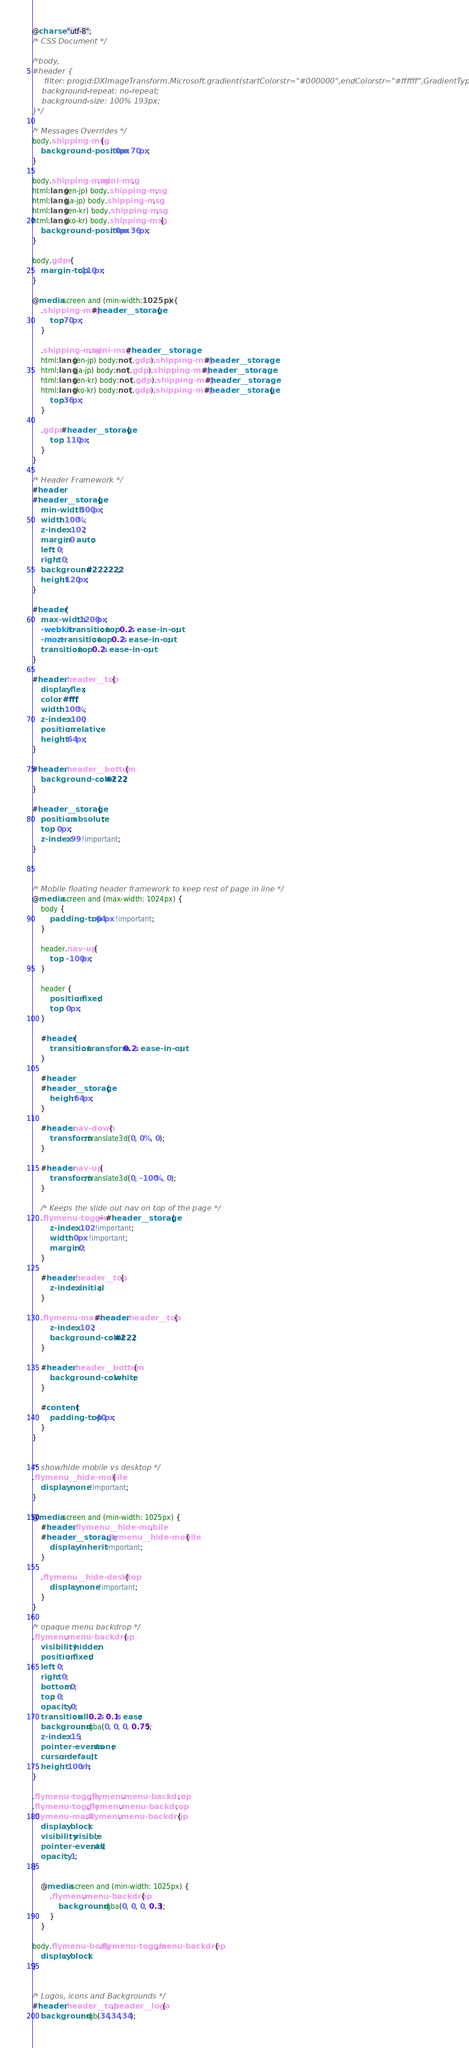Convert code to text. <code><loc_0><loc_0><loc_500><loc_500><_CSS_>@charset "utf-8";
/* CSS Document */

/*body,
#header {
     filter: progid:DXImageTransform.Microsoft.gradient(startColorstr="#000000",endColorstr="#ffffff",GradientType=1);
    background-repeat: no-repeat;
    background-size: 100% 193px; 
}*/

/* Messages Overrides */
body.shipping-msg {
    background-position: 0px 70px;
}

body.shipping-msg.mini-msg,
html:lang(en-jp) body.shipping-msg,
html:lang(ja-jp) body.shipping-msg,
html:lang(en-kr) body.shipping-msg,
html:lang(ko-kr) body.shipping-msg  {
    background-position: 0px 36px;
}

body.gdpr {
    margin-top:110px;
}

@media screen and (min-width:1025px) {
    .shipping-msg #header__storage {
        top:70px;
    }
    
    .shipping-msg.mini-msg #header__storage,
    html:lang(en-jp) body:not(.gdpr).shipping-msg #header__storage,
    html:lang(ja-jp) body:not(.gdpr).shipping-msg #header__storage,
    html:lang(en-kr) body:not(.gdpr).shipping-msg #header__storage,
    html:lang(ko-kr) body:not(.gdpr).shipping-msg #header__storage {
        top:36px;
    }
    
    .gdpr #header__storage {
        top: 110px;
    }
}

/* Header Framework */
#header,
#header__storage {
    min-width: 300px;
    width: 100%;
    z-index: 102;
    margin: 0 auto;
    left: 0;
    right: 0;
    background: #222222;
    height:120px;
}

#header {
    max-width:1200px;
    -webkit-transition: top 0.2s ease-in-out;
    -moz-transition: top 0.2s ease-in-out;
    transition: top 0.2s ease-in-out;
}

#header .header__top {
    display: flex;
    color: #fff;
    width: 100%;
    z-index: 100;
    position: relative;
    height: 64px;
}

#header .header__bottom {
    background-color: #222;
}

#header__storage {
    position: absolute;
    top: 0px;
    z-index: 99 !important;
}



/* Mobile floating header framework to keep rest of page in line */
@media screen and (max-width: 1024px) {
    body {
        padding-top: 64px !important;
    }

    header.nav-up {
        top: -100px;
    }

    header {
        position: fixed;
        top: 0px;
    }

    #header {
        transition: transform 0.2s ease-in-out;
    }

    #header,
    #header__storage {
        height:64px;
    }

    #header.nav-down {
        transform: translate3d(0, 0%, 0);
    }

    #header.nav-up {
        transform: translate3d(0, -100%, 0);
    }

    /* Keeps the slide out nav on top of the page */
    .flymenu-toggle ~ #header__storage {
        z-index: 102 !important;
        width: 0px !important;
        margin: 0;
    }

    #header .header__top {
        z-index: initial;
    }

    .flymenu-mask #header .header__top {
        z-index: 102;
        background-color: #222;
    }

    #header .header__bottom {
        background-color: white;
    }

    #content {
        padding-top: 40px;
    }
}


/* show/hide mobile vs desktop */
.flymenu__hide-mobile {
    display: none !important;
}

@media screen and (min-width: 1025px) {
    #header .flymenu__hide-mobile,
    #header__storage .flymenu__hide-mobile {
        display: inherit !important;
    }

    .flymenu__hide-desktop {
        display: none !important;
    }
}

/* opaque menu backdrop */
.flymenu .menu-backdrop {
    visibility: hidden;
    position: fixed;
    left: 0;
    right: 0;
    bottom: 0;
    top: 0;
    opacity: 0;
    transition: all 0.2s 0.1s ease;
    background: rgba(0, 0, 0, 0.75);
    z-index: 15;
    pointer-events: none;
    cursor: default;
    height: 100vh;
}

.flymenu-toggle .flymenu .menu-backdrop,
.flymenu-toggle.flymenu .menu-backdrop,
.flymenu-mask .flymenu .menu-backdrop {
    display: block;
    visibility: visible;
    pointer-events: all;
    opacity: 1;
}

    @media screen and (min-width: 1025px) {
        .flymenu .menu-backdrop {
            background: rgba(0, 0, 0, 0.3);
        }
    }

body.flymenu-body.flymenu-toggle .menu-backdrop {
    display: block;
}


/* Logos, icons and Backgrounds */
#header .header__top .header__logo {
    background: rgb(34,34,34);</code> 